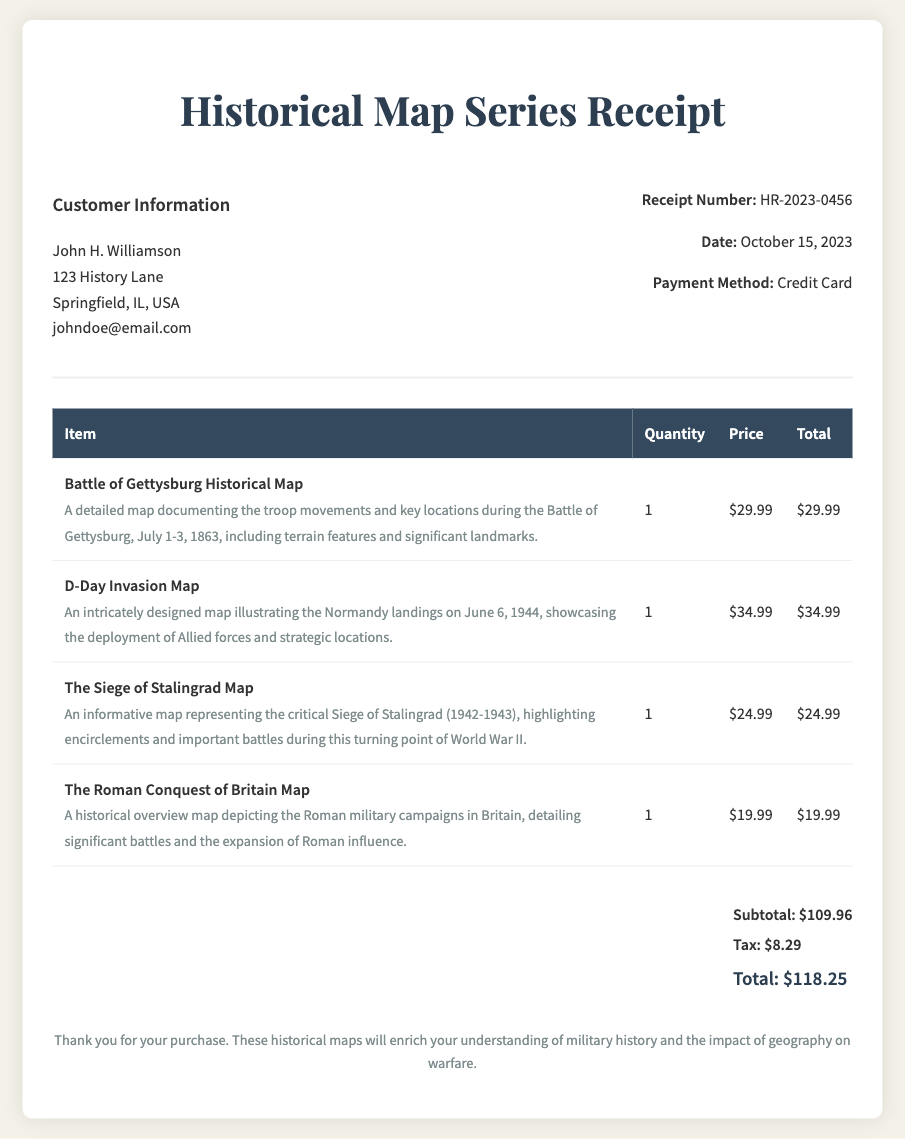What is the receipt number? The receipt number is located in the receipt information section and is labeled clearly.
Answer: HR-2023-0456 Who is the customer? The customer's name is presented at the beginning of the customer information section.
Answer: John H. Williamson What is the transaction date? The date of the transaction is specified in the receipt information and is easy to identify.
Answer: October 15, 2023 How many items were purchased? The document can be analyzed for the number of different items listed in the transaction table.
Answer: 4 What is the price of the D-Day Invasion Map? The price is indicated in the transaction table for each item, specifically listed for the D-Day Invasion Map.
Answer: $34.99 What is the total amount paid? The total amount is presented in the total section at the end of the document, indicating the final payment amount.
Answer: $118.25 What type of payment was used for the transaction? The payment method is mentioned clearly within the receipt information section.
Answer: Credit Card Which historical event is mapped in the Battle of Gettysburg Historical Map? The item description provides information on the historical significance featured in the map.
Answer: Battle of Gettysburg What is the tax amount? The tax amount is specified in the total section of the document, showing the tax charge on the purchase.
Answer: $8.29 